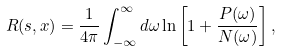<formula> <loc_0><loc_0><loc_500><loc_500>R ( { s } , { x } ) = \frac { 1 } { 4 \pi } \int _ { - \infty } ^ { \infty } d \omega \ln \left [ 1 + \frac { P ( \omega ) } { N ( \omega ) } \right ] ,</formula> 